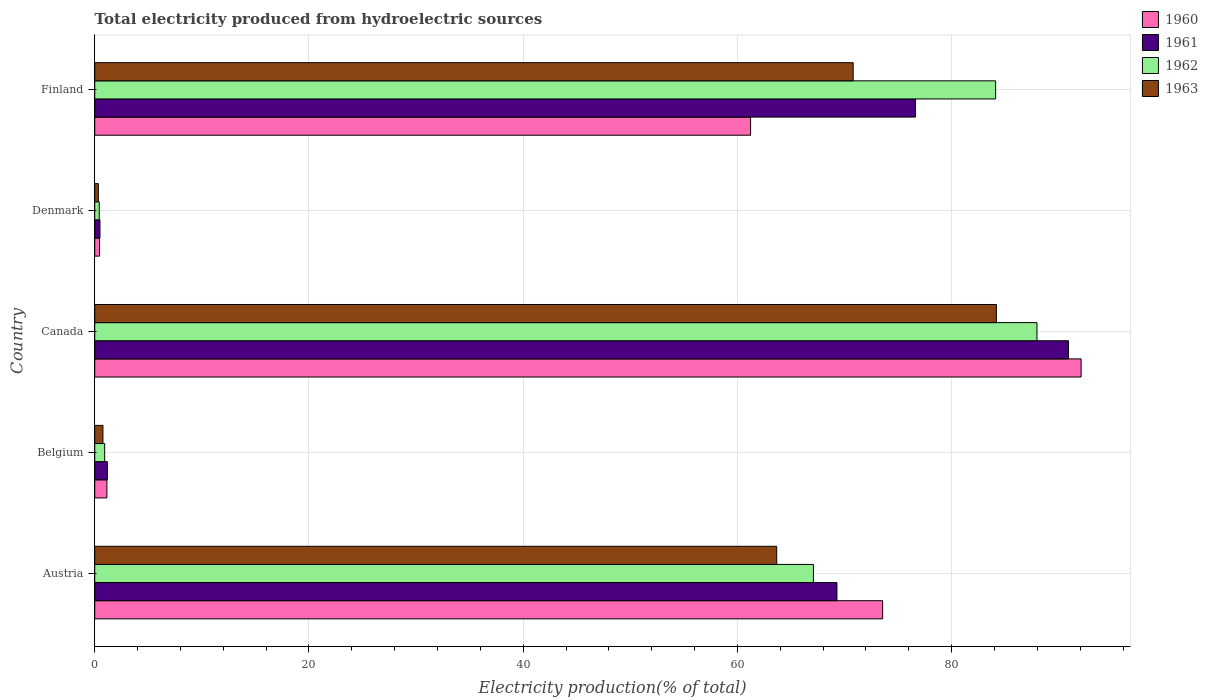How many groups of bars are there?
Ensure brevity in your answer.  5. What is the label of the 4th group of bars from the top?
Provide a short and direct response. Belgium. In how many cases, is the number of bars for a given country not equal to the number of legend labels?
Offer a very short reply. 0. What is the total electricity produced in 1963 in Canada?
Make the answer very short. 84.18. Across all countries, what is the maximum total electricity produced in 1962?
Provide a short and direct response. 87.97. Across all countries, what is the minimum total electricity produced in 1962?
Give a very brief answer. 0.42. In which country was the total electricity produced in 1963 maximum?
Your answer should be compact. Canada. What is the total total electricity produced in 1963 in the graph?
Give a very brief answer. 219.76. What is the difference between the total electricity produced in 1962 in Denmark and that in Finland?
Keep it short and to the point. -83.69. What is the difference between the total electricity produced in 1961 in Austria and the total electricity produced in 1962 in Belgium?
Offer a very short reply. 68.36. What is the average total electricity produced in 1962 per country?
Offer a very short reply. 48.11. What is the difference between the total electricity produced in 1960 and total electricity produced in 1961 in Austria?
Make the answer very short. 4.27. What is the ratio of the total electricity produced in 1962 in Austria to that in Belgium?
Your answer should be compact. 72.22. Is the total electricity produced in 1961 in Austria less than that in Canada?
Your answer should be compact. Yes. Is the difference between the total electricity produced in 1960 in Denmark and Finland greater than the difference between the total electricity produced in 1961 in Denmark and Finland?
Offer a terse response. Yes. What is the difference between the highest and the second highest total electricity produced in 1961?
Your response must be concise. 14.28. What is the difference between the highest and the lowest total electricity produced in 1963?
Give a very brief answer. 83.84. What does the 4th bar from the bottom in Denmark represents?
Provide a succinct answer. 1963. How many bars are there?
Offer a very short reply. 20. What is the difference between two consecutive major ticks on the X-axis?
Provide a succinct answer. 20. Are the values on the major ticks of X-axis written in scientific E-notation?
Ensure brevity in your answer.  No. Does the graph contain grids?
Ensure brevity in your answer.  Yes. How are the legend labels stacked?
Provide a short and direct response. Vertical. What is the title of the graph?
Provide a short and direct response. Total electricity produced from hydroelectric sources. Does "1960" appear as one of the legend labels in the graph?
Your response must be concise. Yes. What is the label or title of the X-axis?
Keep it short and to the point. Electricity production(% of total). What is the Electricity production(% of total) in 1960 in Austria?
Offer a very short reply. 73.56. What is the Electricity production(% of total) of 1961 in Austria?
Keep it short and to the point. 69.29. What is the Electricity production(% of total) in 1962 in Austria?
Provide a succinct answer. 67.1. What is the Electricity production(% of total) in 1963 in Austria?
Your response must be concise. 63.67. What is the Electricity production(% of total) of 1960 in Belgium?
Provide a short and direct response. 1.14. What is the Electricity production(% of total) in 1961 in Belgium?
Your answer should be very brief. 1.18. What is the Electricity production(% of total) of 1962 in Belgium?
Offer a terse response. 0.93. What is the Electricity production(% of total) of 1963 in Belgium?
Offer a very short reply. 0.77. What is the Electricity production(% of total) in 1960 in Canada?
Offer a very short reply. 92.09. What is the Electricity production(% of total) of 1961 in Canada?
Offer a very short reply. 90.91. What is the Electricity production(% of total) in 1962 in Canada?
Provide a short and direct response. 87.97. What is the Electricity production(% of total) of 1963 in Canada?
Keep it short and to the point. 84.18. What is the Electricity production(% of total) in 1960 in Denmark?
Your response must be concise. 0.45. What is the Electricity production(% of total) of 1961 in Denmark?
Make the answer very short. 0.49. What is the Electricity production(% of total) of 1962 in Denmark?
Your response must be concise. 0.42. What is the Electricity production(% of total) in 1963 in Denmark?
Your answer should be very brief. 0.33. What is the Electricity production(% of total) in 1960 in Finland?
Provide a succinct answer. 61.23. What is the Electricity production(% of total) in 1961 in Finland?
Make the answer very short. 76.63. What is the Electricity production(% of total) of 1962 in Finland?
Provide a short and direct response. 84.11. What is the Electricity production(% of total) in 1963 in Finland?
Give a very brief answer. 70.81. Across all countries, what is the maximum Electricity production(% of total) in 1960?
Make the answer very short. 92.09. Across all countries, what is the maximum Electricity production(% of total) of 1961?
Your answer should be very brief. 90.91. Across all countries, what is the maximum Electricity production(% of total) in 1962?
Your response must be concise. 87.97. Across all countries, what is the maximum Electricity production(% of total) in 1963?
Provide a succinct answer. 84.18. Across all countries, what is the minimum Electricity production(% of total) in 1960?
Offer a very short reply. 0.45. Across all countries, what is the minimum Electricity production(% of total) of 1961?
Keep it short and to the point. 0.49. Across all countries, what is the minimum Electricity production(% of total) of 1962?
Give a very brief answer. 0.42. Across all countries, what is the minimum Electricity production(% of total) in 1963?
Ensure brevity in your answer.  0.33. What is the total Electricity production(% of total) of 1960 in the graph?
Offer a terse response. 228.47. What is the total Electricity production(% of total) in 1961 in the graph?
Provide a succinct answer. 238.5. What is the total Electricity production(% of total) in 1962 in the graph?
Provide a short and direct response. 240.53. What is the total Electricity production(% of total) of 1963 in the graph?
Your answer should be compact. 219.76. What is the difference between the Electricity production(% of total) in 1960 in Austria and that in Belgium?
Provide a succinct answer. 72.42. What is the difference between the Electricity production(% of total) of 1961 in Austria and that in Belgium?
Your response must be concise. 68.11. What is the difference between the Electricity production(% of total) in 1962 in Austria and that in Belgium?
Keep it short and to the point. 66.17. What is the difference between the Electricity production(% of total) of 1963 in Austria and that in Belgium?
Ensure brevity in your answer.  62.91. What is the difference between the Electricity production(% of total) in 1960 in Austria and that in Canada?
Make the answer very short. -18.53. What is the difference between the Electricity production(% of total) of 1961 in Austria and that in Canada?
Provide a succinct answer. -21.62. What is the difference between the Electricity production(% of total) in 1962 in Austria and that in Canada?
Provide a succinct answer. -20.87. What is the difference between the Electricity production(% of total) of 1963 in Austria and that in Canada?
Your response must be concise. -20.51. What is the difference between the Electricity production(% of total) of 1960 in Austria and that in Denmark?
Provide a succinct answer. 73.11. What is the difference between the Electricity production(% of total) of 1961 in Austria and that in Denmark?
Keep it short and to the point. 68.8. What is the difference between the Electricity production(% of total) in 1962 in Austria and that in Denmark?
Provide a succinct answer. 66.68. What is the difference between the Electricity production(% of total) in 1963 in Austria and that in Denmark?
Offer a very short reply. 63.34. What is the difference between the Electricity production(% of total) in 1960 in Austria and that in Finland?
Provide a short and direct response. 12.33. What is the difference between the Electricity production(% of total) of 1961 in Austria and that in Finland?
Make the answer very short. -7.33. What is the difference between the Electricity production(% of total) of 1962 in Austria and that in Finland?
Offer a very short reply. -17.01. What is the difference between the Electricity production(% of total) in 1963 in Austria and that in Finland?
Give a very brief answer. -7.14. What is the difference between the Electricity production(% of total) of 1960 in Belgium and that in Canada?
Ensure brevity in your answer.  -90.95. What is the difference between the Electricity production(% of total) of 1961 in Belgium and that in Canada?
Your answer should be very brief. -89.73. What is the difference between the Electricity production(% of total) in 1962 in Belgium and that in Canada?
Offer a very short reply. -87.04. What is the difference between the Electricity production(% of total) in 1963 in Belgium and that in Canada?
Give a very brief answer. -83.41. What is the difference between the Electricity production(% of total) of 1960 in Belgium and that in Denmark?
Give a very brief answer. 0.68. What is the difference between the Electricity production(% of total) in 1961 in Belgium and that in Denmark?
Ensure brevity in your answer.  0.69. What is the difference between the Electricity production(% of total) in 1962 in Belgium and that in Denmark?
Provide a succinct answer. 0.51. What is the difference between the Electricity production(% of total) of 1963 in Belgium and that in Denmark?
Your answer should be very brief. 0.43. What is the difference between the Electricity production(% of total) of 1960 in Belgium and that in Finland?
Ensure brevity in your answer.  -60.1. What is the difference between the Electricity production(% of total) of 1961 in Belgium and that in Finland?
Give a very brief answer. -75.45. What is the difference between the Electricity production(% of total) in 1962 in Belgium and that in Finland?
Keep it short and to the point. -83.18. What is the difference between the Electricity production(% of total) of 1963 in Belgium and that in Finland?
Keep it short and to the point. -70.04. What is the difference between the Electricity production(% of total) of 1960 in Canada and that in Denmark?
Keep it short and to the point. 91.64. What is the difference between the Electricity production(% of total) in 1961 in Canada and that in Denmark?
Keep it short and to the point. 90.42. What is the difference between the Electricity production(% of total) in 1962 in Canada and that in Denmark?
Your answer should be compact. 87.55. What is the difference between the Electricity production(% of total) of 1963 in Canada and that in Denmark?
Make the answer very short. 83.84. What is the difference between the Electricity production(% of total) in 1960 in Canada and that in Finland?
Your response must be concise. 30.86. What is the difference between the Electricity production(% of total) in 1961 in Canada and that in Finland?
Your answer should be very brief. 14.28. What is the difference between the Electricity production(% of total) of 1962 in Canada and that in Finland?
Make the answer very short. 3.86. What is the difference between the Electricity production(% of total) of 1963 in Canada and that in Finland?
Offer a very short reply. 13.37. What is the difference between the Electricity production(% of total) of 1960 in Denmark and that in Finland?
Provide a short and direct response. -60.78. What is the difference between the Electricity production(% of total) of 1961 in Denmark and that in Finland?
Provide a short and direct response. -76.14. What is the difference between the Electricity production(% of total) in 1962 in Denmark and that in Finland?
Keep it short and to the point. -83.69. What is the difference between the Electricity production(% of total) of 1963 in Denmark and that in Finland?
Keep it short and to the point. -70.47. What is the difference between the Electricity production(% of total) in 1960 in Austria and the Electricity production(% of total) in 1961 in Belgium?
Ensure brevity in your answer.  72.38. What is the difference between the Electricity production(% of total) of 1960 in Austria and the Electricity production(% of total) of 1962 in Belgium?
Provide a succinct answer. 72.63. What is the difference between the Electricity production(% of total) in 1960 in Austria and the Electricity production(% of total) in 1963 in Belgium?
Give a very brief answer. 72.79. What is the difference between the Electricity production(% of total) in 1961 in Austria and the Electricity production(% of total) in 1962 in Belgium?
Provide a short and direct response. 68.36. What is the difference between the Electricity production(% of total) of 1961 in Austria and the Electricity production(% of total) of 1963 in Belgium?
Your answer should be very brief. 68.53. What is the difference between the Electricity production(% of total) of 1962 in Austria and the Electricity production(% of total) of 1963 in Belgium?
Offer a terse response. 66.33. What is the difference between the Electricity production(% of total) of 1960 in Austria and the Electricity production(% of total) of 1961 in Canada?
Your answer should be compact. -17.35. What is the difference between the Electricity production(% of total) of 1960 in Austria and the Electricity production(% of total) of 1962 in Canada?
Offer a very short reply. -14.41. What is the difference between the Electricity production(% of total) in 1960 in Austria and the Electricity production(% of total) in 1963 in Canada?
Give a very brief answer. -10.62. What is the difference between the Electricity production(% of total) in 1961 in Austria and the Electricity production(% of total) in 1962 in Canada?
Make the answer very short. -18.67. What is the difference between the Electricity production(% of total) of 1961 in Austria and the Electricity production(% of total) of 1963 in Canada?
Ensure brevity in your answer.  -14.88. What is the difference between the Electricity production(% of total) of 1962 in Austria and the Electricity production(% of total) of 1963 in Canada?
Offer a very short reply. -17.08. What is the difference between the Electricity production(% of total) of 1960 in Austria and the Electricity production(% of total) of 1961 in Denmark?
Make the answer very short. 73.07. What is the difference between the Electricity production(% of total) in 1960 in Austria and the Electricity production(% of total) in 1962 in Denmark?
Your answer should be very brief. 73.14. What is the difference between the Electricity production(% of total) in 1960 in Austria and the Electricity production(% of total) in 1963 in Denmark?
Offer a terse response. 73.22. What is the difference between the Electricity production(% of total) of 1961 in Austria and the Electricity production(% of total) of 1962 in Denmark?
Your answer should be very brief. 68.87. What is the difference between the Electricity production(% of total) of 1961 in Austria and the Electricity production(% of total) of 1963 in Denmark?
Your response must be concise. 68.96. What is the difference between the Electricity production(% of total) in 1962 in Austria and the Electricity production(% of total) in 1963 in Denmark?
Provide a succinct answer. 66.76. What is the difference between the Electricity production(% of total) in 1960 in Austria and the Electricity production(% of total) in 1961 in Finland?
Your response must be concise. -3.07. What is the difference between the Electricity production(% of total) of 1960 in Austria and the Electricity production(% of total) of 1962 in Finland?
Your response must be concise. -10.55. What is the difference between the Electricity production(% of total) in 1960 in Austria and the Electricity production(% of total) in 1963 in Finland?
Offer a very short reply. 2.75. What is the difference between the Electricity production(% of total) in 1961 in Austria and the Electricity production(% of total) in 1962 in Finland?
Ensure brevity in your answer.  -14.81. What is the difference between the Electricity production(% of total) in 1961 in Austria and the Electricity production(% of total) in 1963 in Finland?
Provide a short and direct response. -1.51. What is the difference between the Electricity production(% of total) of 1962 in Austria and the Electricity production(% of total) of 1963 in Finland?
Your response must be concise. -3.71. What is the difference between the Electricity production(% of total) in 1960 in Belgium and the Electricity production(% of total) in 1961 in Canada?
Your answer should be compact. -89.78. What is the difference between the Electricity production(% of total) of 1960 in Belgium and the Electricity production(% of total) of 1962 in Canada?
Provide a short and direct response. -86.83. What is the difference between the Electricity production(% of total) in 1960 in Belgium and the Electricity production(% of total) in 1963 in Canada?
Your response must be concise. -83.04. What is the difference between the Electricity production(% of total) of 1961 in Belgium and the Electricity production(% of total) of 1962 in Canada?
Make the answer very short. -86.79. What is the difference between the Electricity production(% of total) of 1961 in Belgium and the Electricity production(% of total) of 1963 in Canada?
Ensure brevity in your answer.  -83. What is the difference between the Electricity production(% of total) of 1962 in Belgium and the Electricity production(% of total) of 1963 in Canada?
Provide a succinct answer. -83.25. What is the difference between the Electricity production(% of total) of 1960 in Belgium and the Electricity production(% of total) of 1961 in Denmark?
Your answer should be very brief. 0.65. What is the difference between the Electricity production(% of total) in 1960 in Belgium and the Electricity production(% of total) in 1962 in Denmark?
Offer a very short reply. 0.71. What is the difference between the Electricity production(% of total) of 1960 in Belgium and the Electricity production(% of total) of 1963 in Denmark?
Your response must be concise. 0.8. What is the difference between the Electricity production(% of total) in 1961 in Belgium and the Electricity production(% of total) in 1962 in Denmark?
Your answer should be very brief. 0.76. What is the difference between the Electricity production(% of total) of 1961 in Belgium and the Electricity production(% of total) of 1963 in Denmark?
Provide a short and direct response. 0.84. What is the difference between the Electricity production(% of total) in 1962 in Belgium and the Electricity production(% of total) in 1963 in Denmark?
Offer a terse response. 0.59. What is the difference between the Electricity production(% of total) in 1960 in Belgium and the Electricity production(% of total) in 1961 in Finland?
Make the answer very short. -75.49. What is the difference between the Electricity production(% of total) in 1960 in Belgium and the Electricity production(% of total) in 1962 in Finland?
Provide a short and direct response. -82.97. What is the difference between the Electricity production(% of total) in 1960 in Belgium and the Electricity production(% of total) in 1963 in Finland?
Provide a succinct answer. -69.67. What is the difference between the Electricity production(% of total) in 1961 in Belgium and the Electricity production(% of total) in 1962 in Finland?
Your answer should be very brief. -82.93. What is the difference between the Electricity production(% of total) of 1961 in Belgium and the Electricity production(% of total) of 1963 in Finland?
Provide a succinct answer. -69.63. What is the difference between the Electricity production(% of total) of 1962 in Belgium and the Electricity production(% of total) of 1963 in Finland?
Keep it short and to the point. -69.88. What is the difference between the Electricity production(% of total) of 1960 in Canada and the Electricity production(% of total) of 1961 in Denmark?
Offer a terse response. 91.6. What is the difference between the Electricity production(% of total) of 1960 in Canada and the Electricity production(% of total) of 1962 in Denmark?
Provide a succinct answer. 91.67. What is the difference between the Electricity production(% of total) of 1960 in Canada and the Electricity production(% of total) of 1963 in Denmark?
Keep it short and to the point. 91.75. What is the difference between the Electricity production(% of total) in 1961 in Canada and the Electricity production(% of total) in 1962 in Denmark?
Your answer should be compact. 90.49. What is the difference between the Electricity production(% of total) of 1961 in Canada and the Electricity production(% of total) of 1963 in Denmark?
Make the answer very short. 90.58. What is the difference between the Electricity production(% of total) in 1962 in Canada and the Electricity production(% of total) in 1963 in Denmark?
Offer a terse response. 87.63. What is the difference between the Electricity production(% of total) in 1960 in Canada and the Electricity production(% of total) in 1961 in Finland?
Keep it short and to the point. 15.46. What is the difference between the Electricity production(% of total) of 1960 in Canada and the Electricity production(% of total) of 1962 in Finland?
Your answer should be very brief. 7.98. What is the difference between the Electricity production(% of total) in 1960 in Canada and the Electricity production(% of total) in 1963 in Finland?
Keep it short and to the point. 21.28. What is the difference between the Electricity production(% of total) of 1961 in Canada and the Electricity production(% of total) of 1962 in Finland?
Your answer should be compact. 6.8. What is the difference between the Electricity production(% of total) of 1961 in Canada and the Electricity production(% of total) of 1963 in Finland?
Provide a succinct answer. 20.1. What is the difference between the Electricity production(% of total) of 1962 in Canada and the Electricity production(% of total) of 1963 in Finland?
Make the answer very short. 17.16. What is the difference between the Electricity production(% of total) in 1960 in Denmark and the Electricity production(% of total) in 1961 in Finland?
Give a very brief answer. -76.18. What is the difference between the Electricity production(% of total) in 1960 in Denmark and the Electricity production(% of total) in 1962 in Finland?
Provide a short and direct response. -83.66. What is the difference between the Electricity production(% of total) in 1960 in Denmark and the Electricity production(% of total) in 1963 in Finland?
Provide a short and direct response. -70.36. What is the difference between the Electricity production(% of total) of 1961 in Denmark and the Electricity production(% of total) of 1962 in Finland?
Make the answer very short. -83.62. What is the difference between the Electricity production(% of total) of 1961 in Denmark and the Electricity production(% of total) of 1963 in Finland?
Make the answer very short. -70.32. What is the difference between the Electricity production(% of total) in 1962 in Denmark and the Electricity production(% of total) in 1963 in Finland?
Keep it short and to the point. -70.39. What is the average Electricity production(% of total) of 1960 per country?
Offer a terse response. 45.69. What is the average Electricity production(% of total) in 1961 per country?
Offer a very short reply. 47.7. What is the average Electricity production(% of total) of 1962 per country?
Provide a succinct answer. 48.11. What is the average Electricity production(% of total) in 1963 per country?
Offer a terse response. 43.95. What is the difference between the Electricity production(% of total) of 1960 and Electricity production(% of total) of 1961 in Austria?
Make the answer very short. 4.27. What is the difference between the Electricity production(% of total) in 1960 and Electricity production(% of total) in 1962 in Austria?
Make the answer very short. 6.46. What is the difference between the Electricity production(% of total) of 1960 and Electricity production(% of total) of 1963 in Austria?
Keep it short and to the point. 9.89. What is the difference between the Electricity production(% of total) in 1961 and Electricity production(% of total) in 1962 in Austria?
Give a very brief answer. 2.19. What is the difference between the Electricity production(% of total) in 1961 and Electricity production(% of total) in 1963 in Austria?
Your response must be concise. 5.62. What is the difference between the Electricity production(% of total) of 1962 and Electricity production(% of total) of 1963 in Austria?
Make the answer very short. 3.43. What is the difference between the Electricity production(% of total) of 1960 and Electricity production(% of total) of 1961 in Belgium?
Your answer should be very brief. -0.04. What is the difference between the Electricity production(% of total) in 1960 and Electricity production(% of total) in 1962 in Belgium?
Ensure brevity in your answer.  0.21. What is the difference between the Electricity production(% of total) of 1960 and Electricity production(% of total) of 1963 in Belgium?
Your answer should be very brief. 0.37. What is the difference between the Electricity production(% of total) of 1961 and Electricity production(% of total) of 1962 in Belgium?
Make the answer very short. 0.25. What is the difference between the Electricity production(% of total) in 1961 and Electricity production(% of total) in 1963 in Belgium?
Your response must be concise. 0.41. What is the difference between the Electricity production(% of total) of 1962 and Electricity production(% of total) of 1963 in Belgium?
Ensure brevity in your answer.  0.16. What is the difference between the Electricity production(% of total) of 1960 and Electricity production(% of total) of 1961 in Canada?
Offer a very short reply. 1.18. What is the difference between the Electricity production(% of total) of 1960 and Electricity production(% of total) of 1962 in Canada?
Ensure brevity in your answer.  4.12. What is the difference between the Electricity production(% of total) of 1960 and Electricity production(% of total) of 1963 in Canada?
Offer a terse response. 7.91. What is the difference between the Electricity production(% of total) in 1961 and Electricity production(% of total) in 1962 in Canada?
Your answer should be compact. 2.94. What is the difference between the Electricity production(% of total) in 1961 and Electricity production(% of total) in 1963 in Canada?
Make the answer very short. 6.73. What is the difference between the Electricity production(% of total) in 1962 and Electricity production(% of total) in 1963 in Canada?
Ensure brevity in your answer.  3.79. What is the difference between the Electricity production(% of total) in 1960 and Electricity production(% of total) in 1961 in Denmark?
Give a very brief answer. -0.04. What is the difference between the Electricity production(% of total) in 1960 and Electricity production(% of total) in 1962 in Denmark?
Offer a terse response. 0.03. What is the difference between the Electricity production(% of total) in 1960 and Electricity production(% of total) in 1963 in Denmark?
Offer a very short reply. 0.12. What is the difference between the Electricity production(% of total) of 1961 and Electricity production(% of total) of 1962 in Denmark?
Keep it short and to the point. 0.07. What is the difference between the Electricity production(% of total) of 1961 and Electricity production(% of total) of 1963 in Denmark?
Your answer should be compact. 0.15. What is the difference between the Electricity production(% of total) of 1962 and Electricity production(% of total) of 1963 in Denmark?
Your response must be concise. 0.09. What is the difference between the Electricity production(% of total) of 1960 and Electricity production(% of total) of 1961 in Finland?
Offer a terse response. -15.4. What is the difference between the Electricity production(% of total) of 1960 and Electricity production(% of total) of 1962 in Finland?
Keep it short and to the point. -22.88. What is the difference between the Electricity production(% of total) of 1960 and Electricity production(% of total) of 1963 in Finland?
Provide a short and direct response. -9.58. What is the difference between the Electricity production(% of total) in 1961 and Electricity production(% of total) in 1962 in Finland?
Give a very brief answer. -7.48. What is the difference between the Electricity production(% of total) in 1961 and Electricity production(% of total) in 1963 in Finland?
Provide a succinct answer. 5.82. What is the difference between the Electricity production(% of total) of 1962 and Electricity production(% of total) of 1963 in Finland?
Give a very brief answer. 13.3. What is the ratio of the Electricity production(% of total) in 1960 in Austria to that in Belgium?
Make the answer very short. 64.8. What is the ratio of the Electricity production(% of total) in 1961 in Austria to that in Belgium?
Give a very brief answer. 58.77. What is the ratio of the Electricity production(% of total) of 1962 in Austria to that in Belgium?
Ensure brevity in your answer.  72.22. What is the ratio of the Electricity production(% of total) of 1963 in Austria to that in Belgium?
Offer a very short reply. 83.18. What is the ratio of the Electricity production(% of total) of 1960 in Austria to that in Canada?
Provide a succinct answer. 0.8. What is the ratio of the Electricity production(% of total) in 1961 in Austria to that in Canada?
Your answer should be very brief. 0.76. What is the ratio of the Electricity production(% of total) of 1962 in Austria to that in Canada?
Ensure brevity in your answer.  0.76. What is the ratio of the Electricity production(% of total) of 1963 in Austria to that in Canada?
Your answer should be compact. 0.76. What is the ratio of the Electricity production(% of total) of 1960 in Austria to that in Denmark?
Your answer should be compact. 163.01. What is the ratio of the Electricity production(% of total) of 1961 in Austria to that in Denmark?
Offer a terse response. 141.68. What is the ratio of the Electricity production(% of total) in 1962 in Austria to that in Denmark?
Give a very brief answer. 159.41. What is the ratio of the Electricity production(% of total) of 1963 in Austria to that in Denmark?
Your answer should be compact. 190.38. What is the ratio of the Electricity production(% of total) of 1960 in Austria to that in Finland?
Offer a very short reply. 1.2. What is the ratio of the Electricity production(% of total) of 1961 in Austria to that in Finland?
Your response must be concise. 0.9. What is the ratio of the Electricity production(% of total) of 1962 in Austria to that in Finland?
Offer a terse response. 0.8. What is the ratio of the Electricity production(% of total) in 1963 in Austria to that in Finland?
Keep it short and to the point. 0.9. What is the ratio of the Electricity production(% of total) in 1960 in Belgium to that in Canada?
Give a very brief answer. 0.01. What is the ratio of the Electricity production(% of total) in 1961 in Belgium to that in Canada?
Make the answer very short. 0.01. What is the ratio of the Electricity production(% of total) in 1962 in Belgium to that in Canada?
Keep it short and to the point. 0.01. What is the ratio of the Electricity production(% of total) of 1963 in Belgium to that in Canada?
Ensure brevity in your answer.  0.01. What is the ratio of the Electricity production(% of total) of 1960 in Belgium to that in Denmark?
Your response must be concise. 2.52. What is the ratio of the Electricity production(% of total) in 1961 in Belgium to that in Denmark?
Give a very brief answer. 2.41. What is the ratio of the Electricity production(% of total) in 1962 in Belgium to that in Denmark?
Make the answer very short. 2.21. What is the ratio of the Electricity production(% of total) of 1963 in Belgium to that in Denmark?
Provide a short and direct response. 2.29. What is the ratio of the Electricity production(% of total) in 1960 in Belgium to that in Finland?
Ensure brevity in your answer.  0.02. What is the ratio of the Electricity production(% of total) of 1961 in Belgium to that in Finland?
Your answer should be compact. 0.02. What is the ratio of the Electricity production(% of total) in 1962 in Belgium to that in Finland?
Offer a very short reply. 0.01. What is the ratio of the Electricity production(% of total) of 1963 in Belgium to that in Finland?
Your answer should be very brief. 0.01. What is the ratio of the Electricity production(% of total) of 1960 in Canada to that in Denmark?
Offer a terse response. 204.07. What is the ratio of the Electricity production(% of total) in 1961 in Canada to that in Denmark?
Ensure brevity in your answer.  185.88. What is the ratio of the Electricity production(% of total) of 1962 in Canada to that in Denmark?
Make the answer very short. 208.99. What is the ratio of the Electricity production(% of total) in 1963 in Canada to that in Denmark?
Make the answer very short. 251.69. What is the ratio of the Electricity production(% of total) in 1960 in Canada to that in Finland?
Offer a very short reply. 1.5. What is the ratio of the Electricity production(% of total) of 1961 in Canada to that in Finland?
Offer a very short reply. 1.19. What is the ratio of the Electricity production(% of total) of 1962 in Canada to that in Finland?
Your answer should be compact. 1.05. What is the ratio of the Electricity production(% of total) of 1963 in Canada to that in Finland?
Give a very brief answer. 1.19. What is the ratio of the Electricity production(% of total) in 1960 in Denmark to that in Finland?
Offer a very short reply. 0.01. What is the ratio of the Electricity production(% of total) of 1961 in Denmark to that in Finland?
Ensure brevity in your answer.  0.01. What is the ratio of the Electricity production(% of total) in 1962 in Denmark to that in Finland?
Provide a succinct answer. 0.01. What is the ratio of the Electricity production(% of total) of 1963 in Denmark to that in Finland?
Your response must be concise. 0. What is the difference between the highest and the second highest Electricity production(% of total) of 1960?
Offer a very short reply. 18.53. What is the difference between the highest and the second highest Electricity production(% of total) of 1961?
Ensure brevity in your answer.  14.28. What is the difference between the highest and the second highest Electricity production(% of total) of 1962?
Offer a very short reply. 3.86. What is the difference between the highest and the second highest Electricity production(% of total) of 1963?
Offer a very short reply. 13.37. What is the difference between the highest and the lowest Electricity production(% of total) in 1960?
Provide a succinct answer. 91.64. What is the difference between the highest and the lowest Electricity production(% of total) in 1961?
Your answer should be compact. 90.42. What is the difference between the highest and the lowest Electricity production(% of total) in 1962?
Offer a terse response. 87.55. What is the difference between the highest and the lowest Electricity production(% of total) in 1963?
Provide a short and direct response. 83.84. 